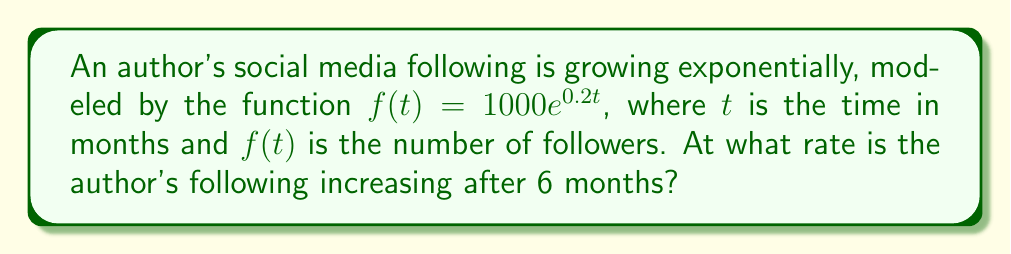Teach me how to tackle this problem. To find the rate of increase after 6 months, we need to calculate the derivative of the given function and evaluate it at $t=6$.

Step 1: Find the derivative of $f(t)$.
The derivative of $e^x$ is $e^x$, so we can use the chain rule:
$$f'(t) = 1000 \cdot 0.2e^{0.2t} = 200e^{0.2t}$$

Step 2: Evaluate $f'(6)$.
$$f'(6) = 200e^{0.2 \cdot 6} = 200e^{1.2} \approx 662.9$$

Step 3: Interpret the result.
The rate of increase after 6 months is approximately 663 followers per month.

Note: As a professional commercial fiction writer, you might feel defensive about focusing on social media growth rates rather than your creative process. However, understanding your audience growth can be valuable for career development and reader engagement.
Answer: $200e^{1.2}$ followers/month 